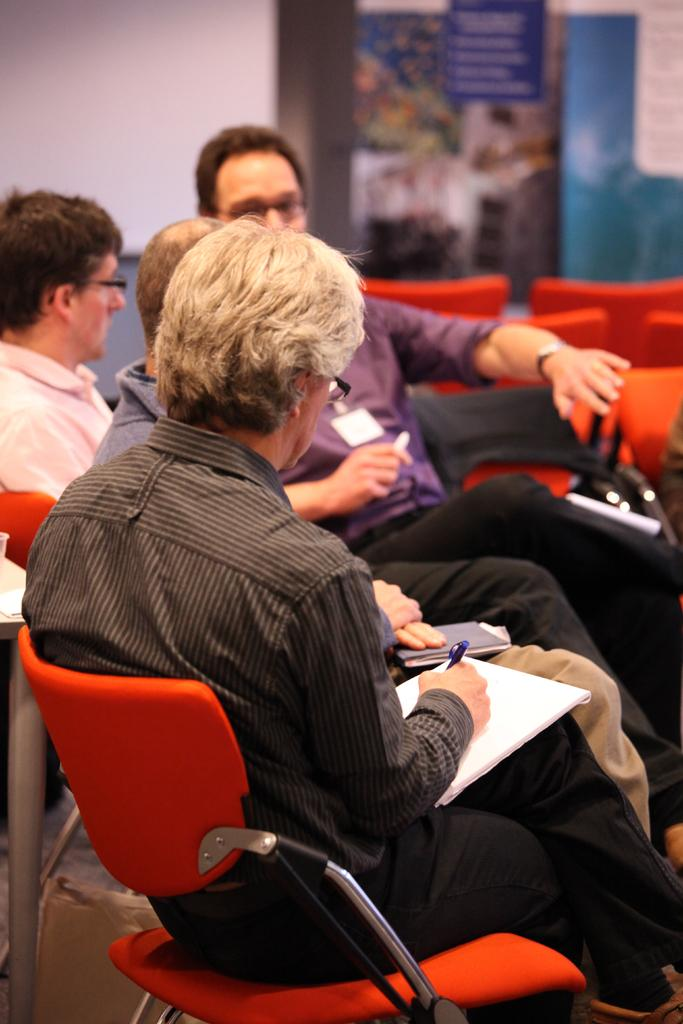What is the color of the wall in the image? The wall in the image is white. What are the people in the image doing? The people in the image are sitting on chairs. What is the man holding in the image? The man is holding papers and a pen in the image. Can you see a maid cleaning the floor in the image? There is no maid or cleaning activity depicted in the image. Are there any animals from a zoo present in the image? There are no animals or references to a zoo in the image. 